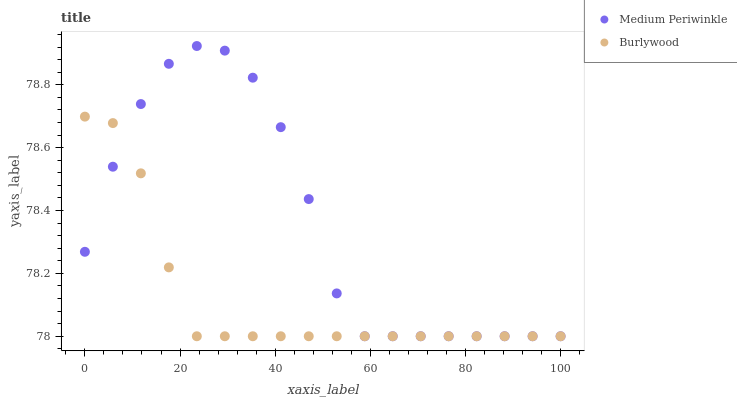Does Burlywood have the minimum area under the curve?
Answer yes or no. Yes. Does Medium Periwinkle have the maximum area under the curve?
Answer yes or no. Yes. Does Medium Periwinkle have the minimum area under the curve?
Answer yes or no. No. Is Burlywood the smoothest?
Answer yes or no. Yes. Is Medium Periwinkle the roughest?
Answer yes or no. Yes. Is Medium Periwinkle the smoothest?
Answer yes or no. No. Does Burlywood have the lowest value?
Answer yes or no. Yes. Does Medium Periwinkle have the highest value?
Answer yes or no. Yes. Does Medium Periwinkle intersect Burlywood?
Answer yes or no. Yes. Is Medium Periwinkle less than Burlywood?
Answer yes or no. No. Is Medium Periwinkle greater than Burlywood?
Answer yes or no. No. 